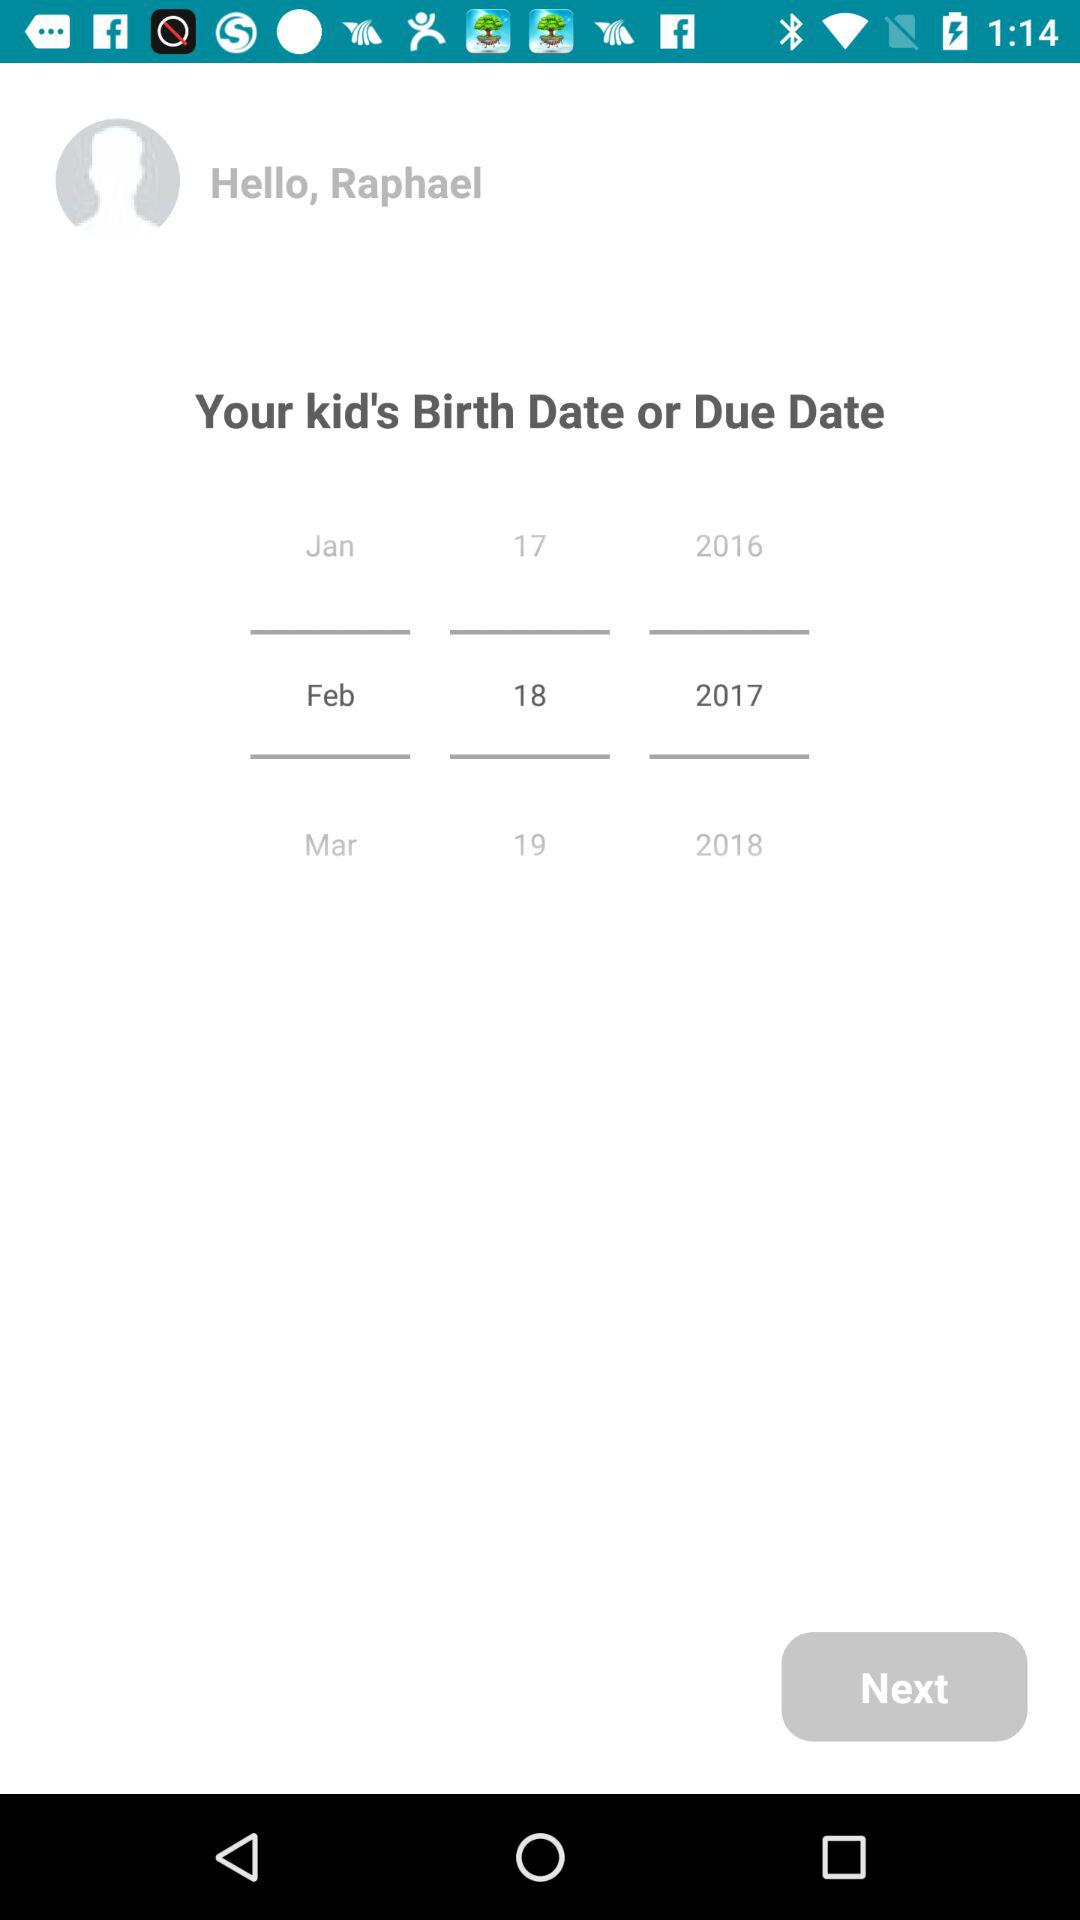What is the date of birth? The date of birth is February 18, 2017. 